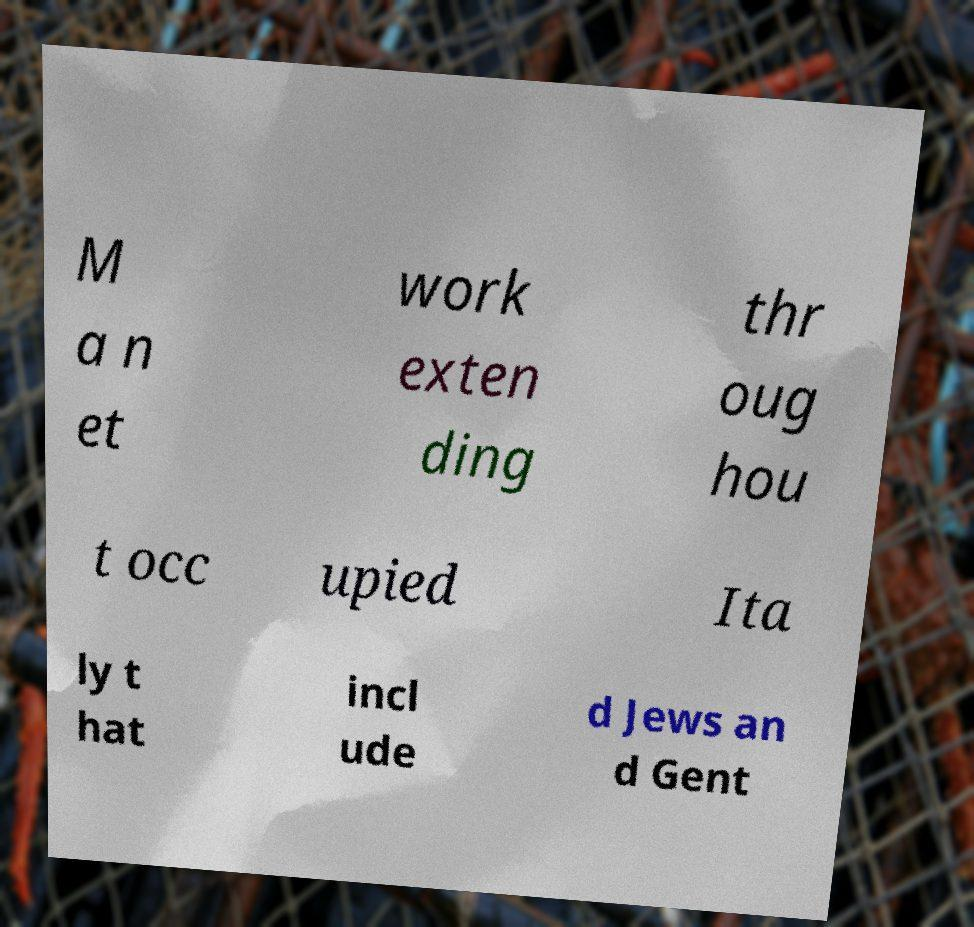There's text embedded in this image that I need extracted. Can you transcribe it verbatim? M a n et work exten ding thr oug hou t occ upied Ita ly t hat incl ude d Jews an d Gent 